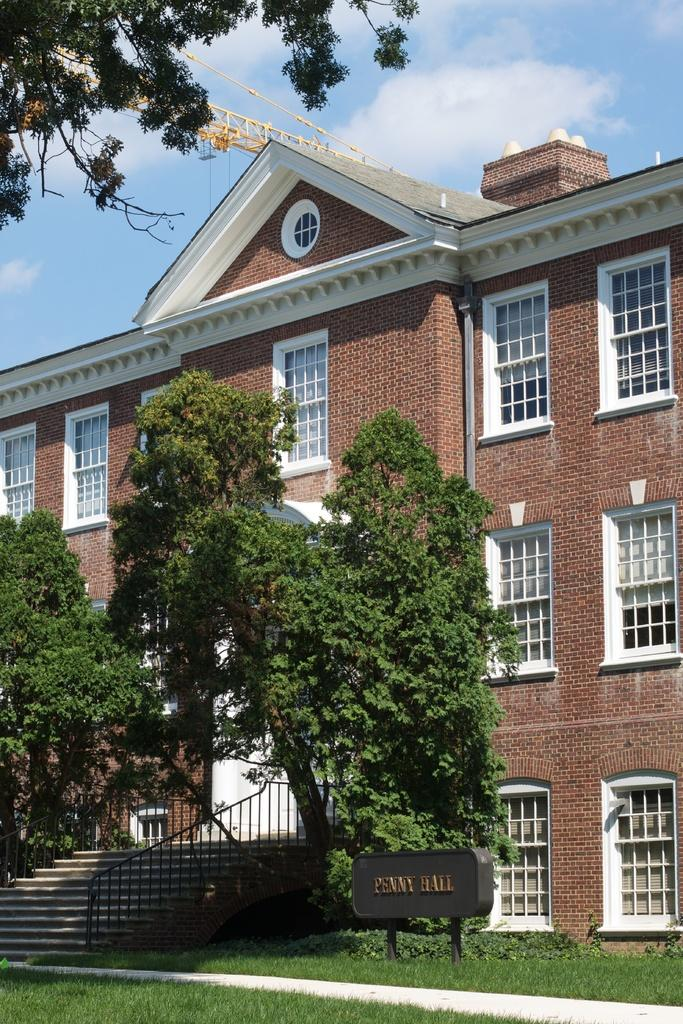What type of structure is present in the image? There is a building in the image. What type of vegetation can be seen in the image? There are trees and grass in the image. What is the board in the image used for? The purpose of the board in the image is not specified, but it is present in the image. How many maids are visible in the image? There are no maids present in the image. What type of pump is used to water the grass in the image? There is no pump visible in the image, and the grass does not appear to be watered. 